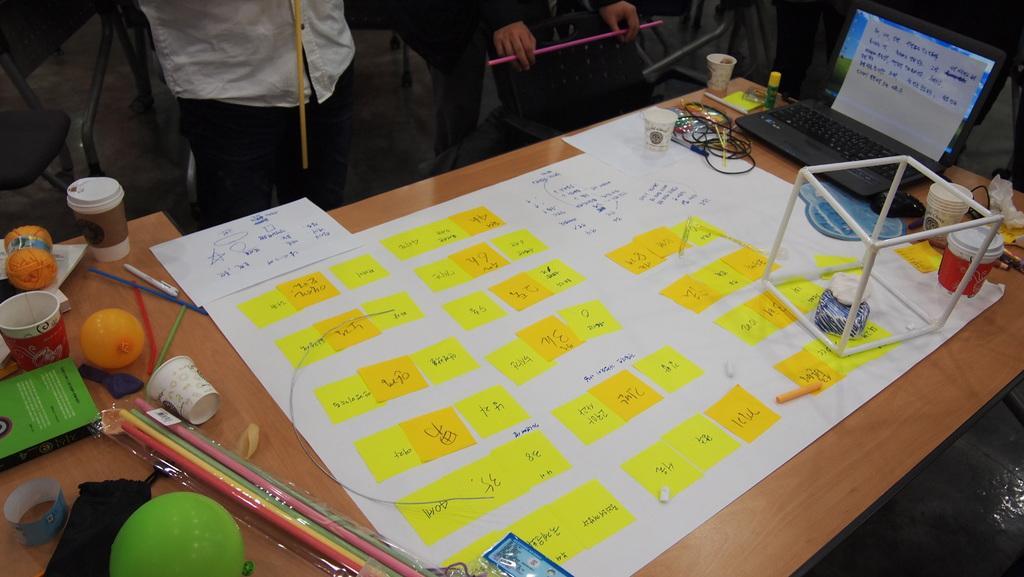In one or two sentences, can you explain what this image depicts? In this image I can see a chart,chup,balloon,pen,laptop and a wire on the table. There are few persons standing. 